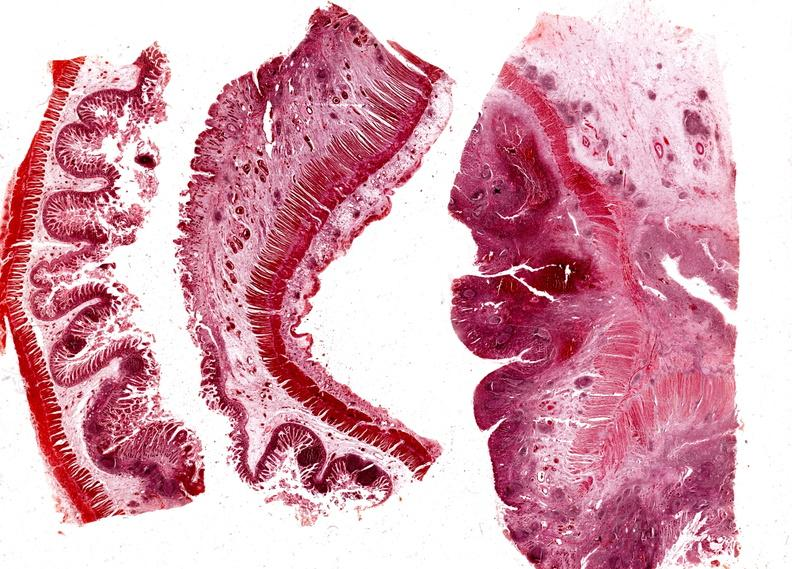what is present?
Answer the question using a single word or phrase. Gastrointestinal 